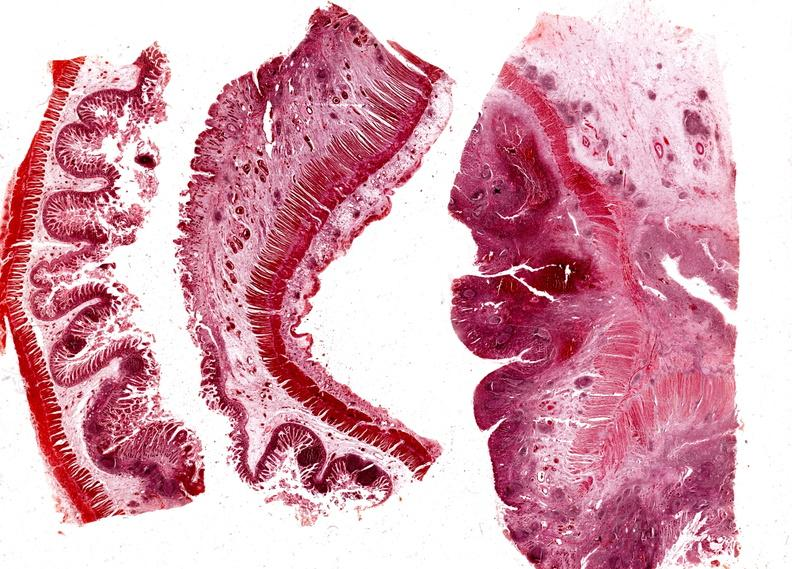what is present?
Answer the question using a single word or phrase. Gastrointestinal 